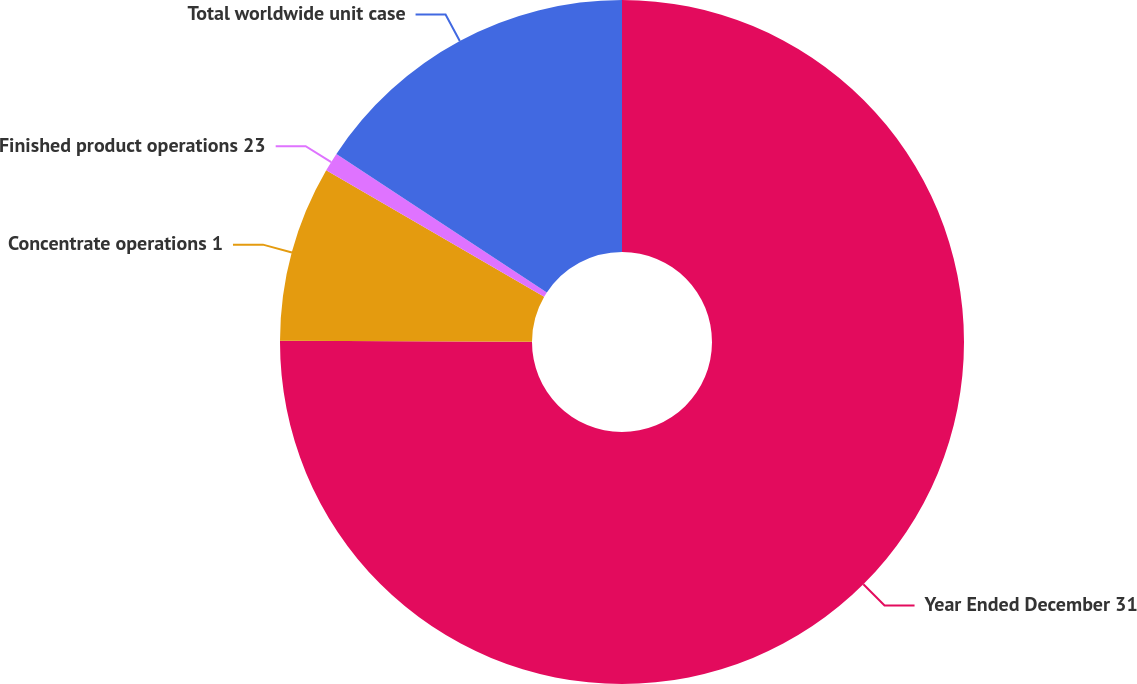Convert chart. <chart><loc_0><loc_0><loc_500><loc_500><pie_chart><fcel>Year Ended December 31<fcel>Concentrate operations 1<fcel>Finished product operations 23<fcel>Total worldwide unit case<nl><fcel>75.06%<fcel>8.31%<fcel>0.9%<fcel>15.73%<nl></chart> 